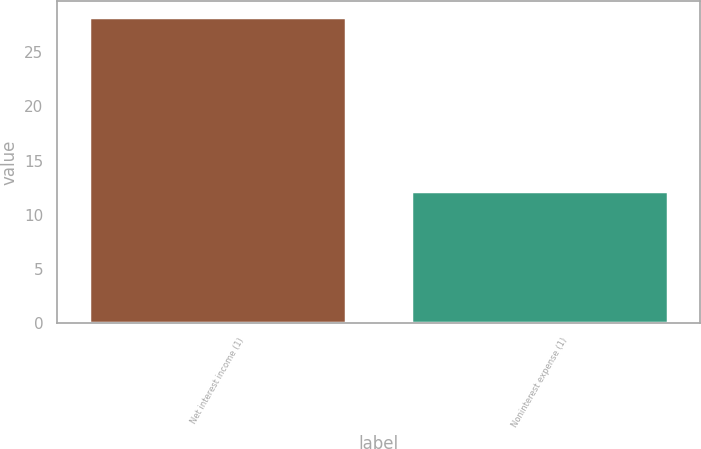Convert chart to OTSL. <chart><loc_0><loc_0><loc_500><loc_500><bar_chart><fcel>Net interest income (1)<fcel>Noninterest expense (1)<nl><fcel>28.3<fcel>12.2<nl></chart> 